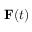<formula> <loc_0><loc_0><loc_500><loc_500>{ F } ( t )</formula> 